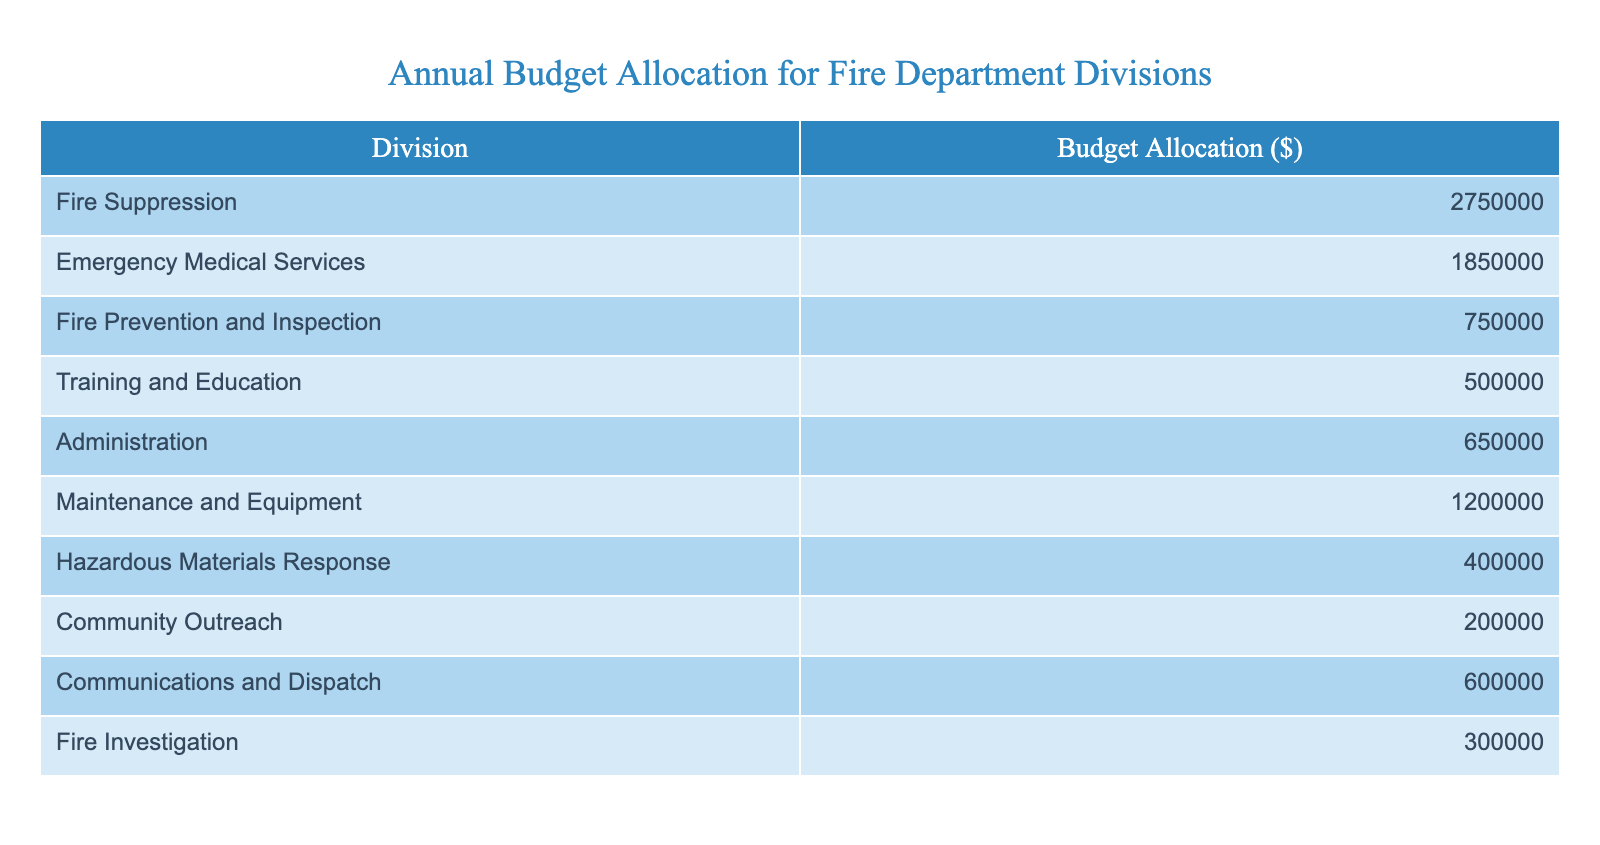What is the budget allocation for Emergency Medical Services? The table clearly states that the budget allocation for Emergency Medical Services is 1,850,000 dollars.
Answer: 1,850,000 What division has the highest budget allocation? By examining the values in the table, we see that Fire Suppression has the highest budget allocation at 2,750,000 dollars.
Answer: Fire Suppression What is the combined budget of Training and Education and Administration? The budget for Training and Education is 500,000 dollars and for Administration is 650,000 dollars. Adding these two amounts gives 500,000 + 650,000 = 1,150,000 dollars.
Answer: 1,150,000 Is the budget for Fire Prevention and Inspection more than 700,000 dollars? The table shows that the budget for Fire Prevention and Inspection is 750,000 dollars, which is indeed more than 700,000 dollars.
Answer: Yes What percentage of the total budget does Communications and Dispatch represent? First, we need to find the total budget by summing all divisions: 2,750,000 + 1,850,000 + 750,000 + 500,000 + 650,000 + 1,200,000 + 400,000 + 200,000 + 600,000 + 300,000 = 10,200,000 dollars. The budget for Communications and Dispatch is 600,000 dollars. To find the percentage, we calculate (600,000 / 10,200,000) * 100 = 5.88%.
Answer: 5.88% Which division has a budget allocation less than 500,000 dollars? Looking through the table, only Community Outreach has a budget of 200,000 dollars, which is less than 500,000 dollars.
Answer: Community Outreach What is the difference between the budget allocations of Fire Investigation and Hazardous Materials Response? The budget for Fire Investigation is 300,000 dollars and for Hazardous Materials Response is 400,000 dollars. The difference is 400,000 - 300,000 = 100,000 dollars.
Answer: 100,000 How much more is allocated to Fire Suppression compared to Community Outreach? The budget for Fire Suppression is 2,750,000 dollars and for Community Outreach it is 200,000 dollars. The difference is 2,750,000 - 200,000 = 2,550,000 dollars.
Answer: 2,550,000 What is the total budget allocated for all divisions? To find the total, we sum the allocations for all divisions: 2,750,000 + 1,850,000 + 750,000 + 500,000 + 650,000 + 1,200,000 + 400,000 + 200,000 + 600,000 + 300,000 = 10,200,000 dollars.
Answer: 10,200,000 